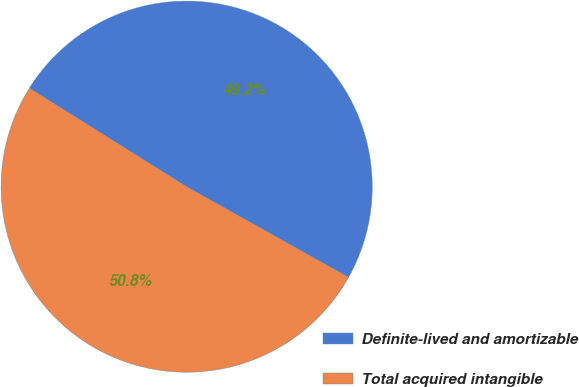<chart> <loc_0><loc_0><loc_500><loc_500><pie_chart><fcel>Definite-lived and amortizable<fcel>Total acquired intangible<nl><fcel>49.21%<fcel>50.79%<nl></chart> 